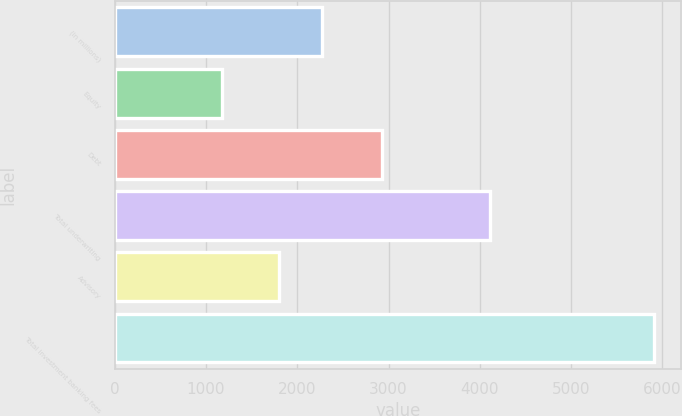Convert chart. <chart><loc_0><loc_0><loc_500><loc_500><bar_chart><fcel>(in millions)<fcel>Equity<fcel>Debt<fcel>Total underwriting<fcel>Advisory<fcel>Total investment banking fees<nl><fcel>2269<fcel>1181<fcel>2934<fcel>4115<fcel>1796<fcel>5911<nl></chart> 